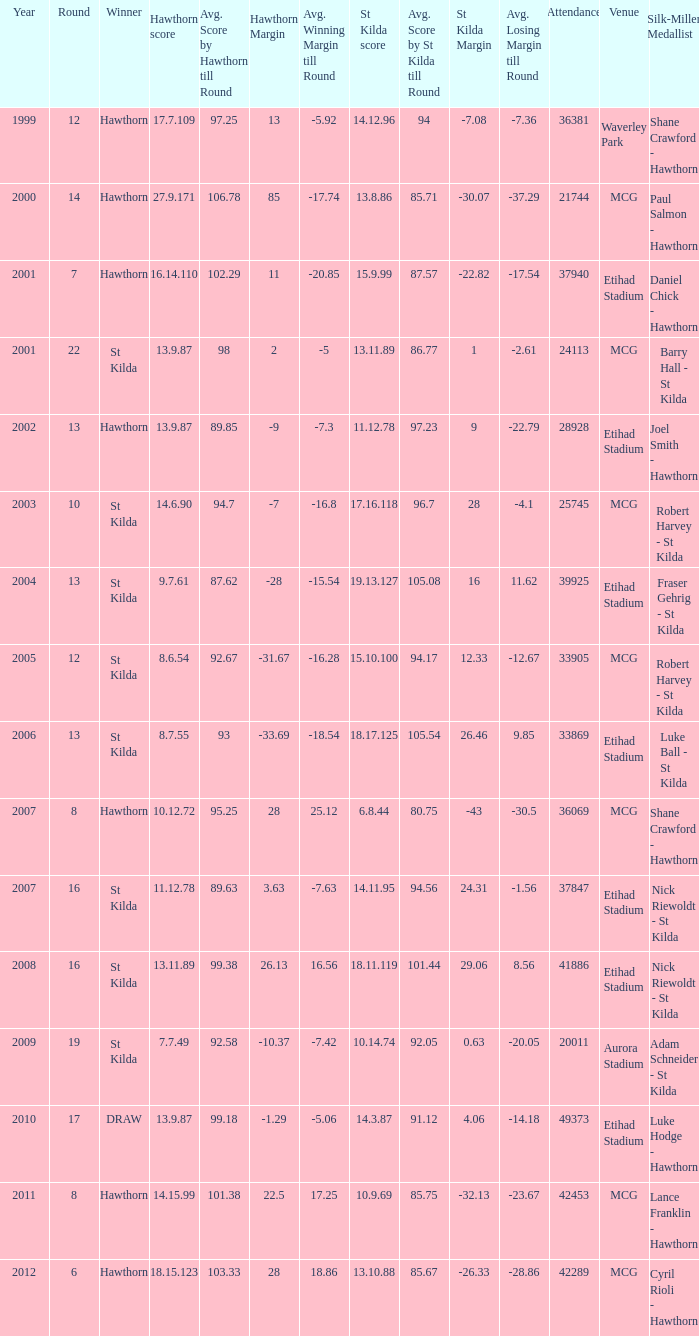What is the attendance when the hawthorn score is 18.15.123? 42289.0. 